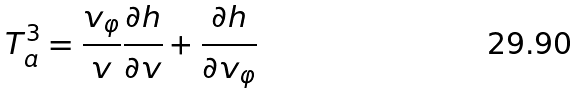Convert formula to latex. <formula><loc_0><loc_0><loc_500><loc_500>T _ { a } ^ { 3 } = \frac { v _ { \varphi } } { v } \frac { \partial h } { \partial v } + \frac { \partial h } { \partial v _ { \varphi } }</formula> 